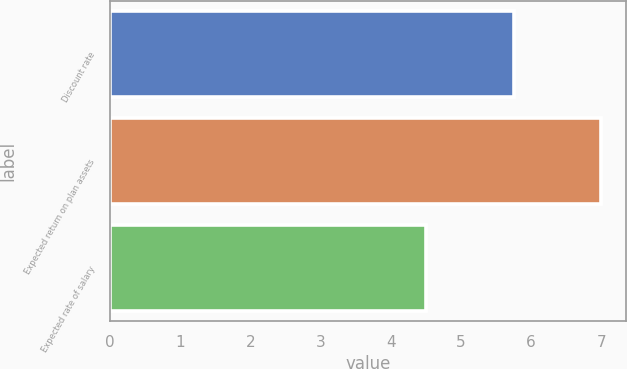Convert chart. <chart><loc_0><loc_0><loc_500><loc_500><bar_chart><fcel>Discount rate<fcel>Expected return on plan assets<fcel>Expected rate of salary<nl><fcel>5.75<fcel>7<fcel>4.5<nl></chart> 